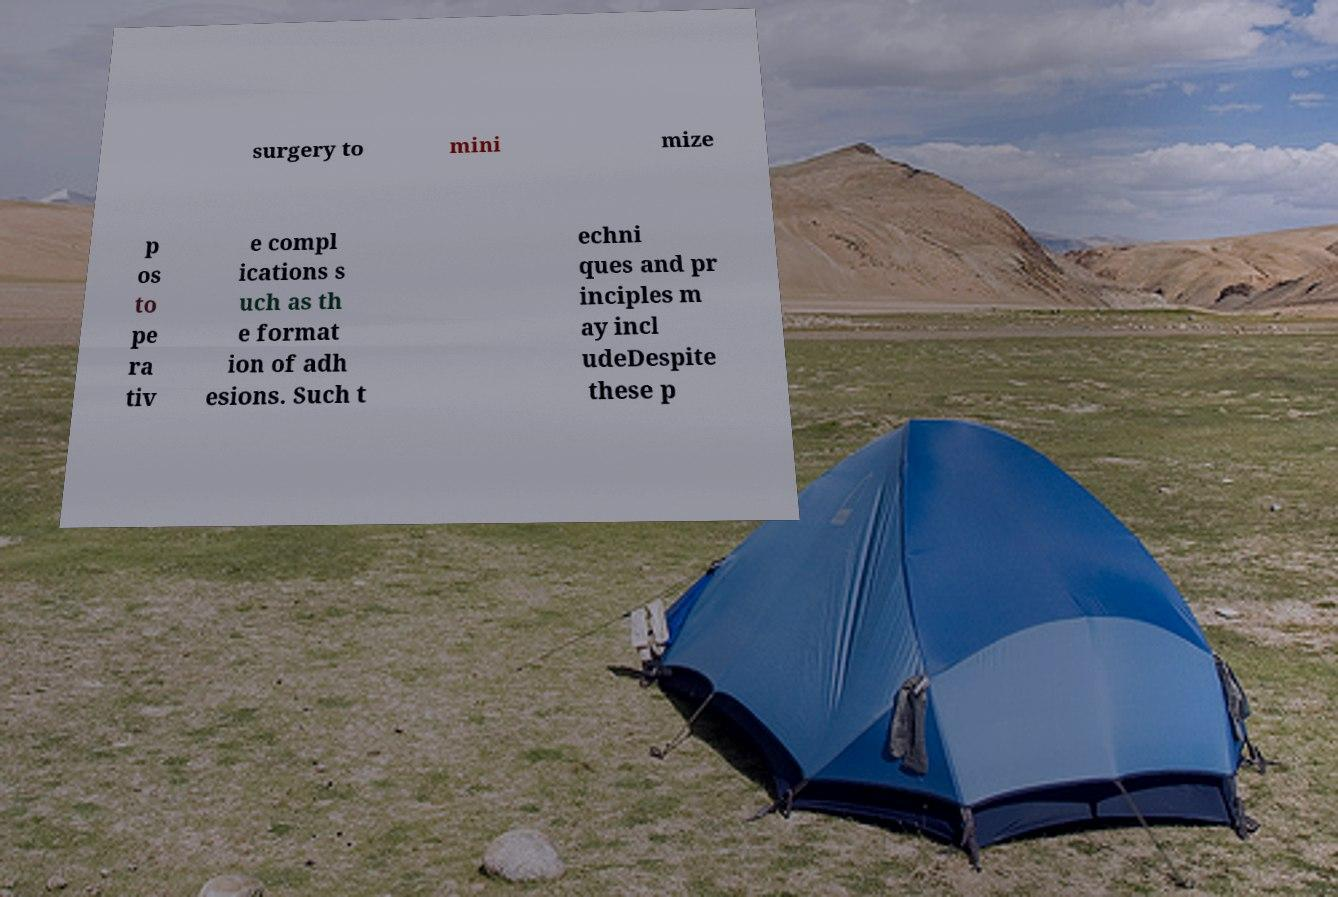Can you accurately transcribe the text from the provided image for me? surgery to mini mize p os to pe ra tiv e compl ications s uch as th e format ion of adh esions. Such t echni ques and pr inciples m ay incl udeDespite these p 